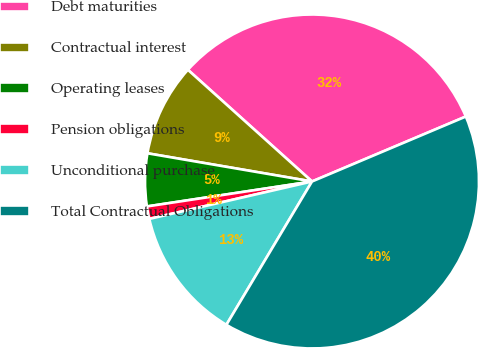<chart> <loc_0><loc_0><loc_500><loc_500><pie_chart><fcel>Debt maturities<fcel>Contractual interest<fcel>Operating leases<fcel>Pension obligations<fcel>Unconditional purchase<fcel>Total Contractual Obligations<nl><fcel>31.98%<fcel>8.96%<fcel>5.09%<fcel>1.21%<fcel>12.83%<fcel>39.93%<nl></chart> 